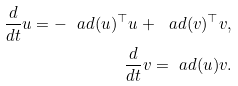<formula> <loc_0><loc_0><loc_500><loc_500>\frac { d } { d t } u = - \ a d ( u ) ^ { \top } u + \ a d ( v ) ^ { \top } v , \\ \frac { d } { d t } v = \ a d ( u ) v .</formula> 